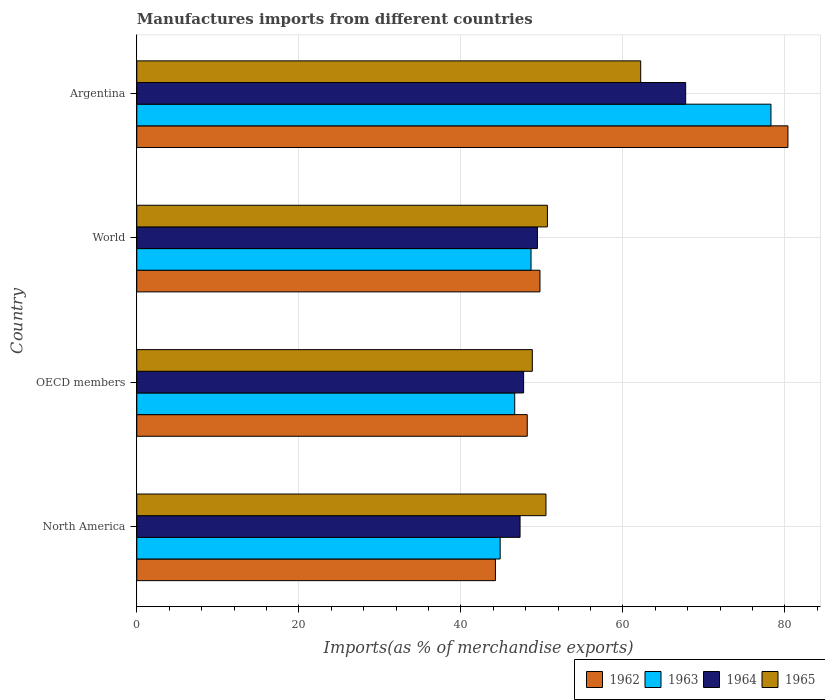How many different coloured bars are there?
Provide a succinct answer. 4. How many groups of bars are there?
Make the answer very short. 4. Are the number of bars on each tick of the Y-axis equal?
Offer a terse response. Yes. How many bars are there on the 2nd tick from the top?
Keep it short and to the point. 4. How many bars are there on the 1st tick from the bottom?
Ensure brevity in your answer.  4. What is the percentage of imports to different countries in 1964 in OECD members?
Your answer should be compact. 47.75. Across all countries, what is the maximum percentage of imports to different countries in 1962?
Ensure brevity in your answer.  80.37. Across all countries, what is the minimum percentage of imports to different countries in 1963?
Offer a terse response. 44.85. In which country was the percentage of imports to different countries in 1965 minimum?
Your answer should be compact. OECD members. What is the total percentage of imports to different countries in 1964 in the graph?
Keep it short and to the point. 212.24. What is the difference between the percentage of imports to different countries in 1964 in North America and that in World?
Provide a succinct answer. -2.14. What is the difference between the percentage of imports to different countries in 1962 in OECD members and the percentage of imports to different countries in 1963 in Argentina?
Your response must be concise. -30.08. What is the average percentage of imports to different countries in 1963 per country?
Provide a short and direct response. 54.61. What is the difference between the percentage of imports to different countries in 1962 and percentage of imports to different countries in 1964 in World?
Make the answer very short. 0.31. What is the ratio of the percentage of imports to different countries in 1963 in Argentina to that in North America?
Provide a succinct answer. 1.75. Is the percentage of imports to different countries in 1964 in Argentina less than that in North America?
Offer a terse response. No. Is the difference between the percentage of imports to different countries in 1962 in Argentina and OECD members greater than the difference between the percentage of imports to different countries in 1964 in Argentina and OECD members?
Offer a very short reply. Yes. What is the difference between the highest and the second highest percentage of imports to different countries in 1962?
Provide a short and direct response. 30.61. What is the difference between the highest and the lowest percentage of imports to different countries in 1964?
Make the answer very short. 20.44. Is the sum of the percentage of imports to different countries in 1962 in OECD members and World greater than the maximum percentage of imports to different countries in 1964 across all countries?
Offer a terse response. Yes. Is it the case that in every country, the sum of the percentage of imports to different countries in 1963 and percentage of imports to different countries in 1962 is greater than the sum of percentage of imports to different countries in 1964 and percentage of imports to different countries in 1965?
Offer a very short reply. No. What does the 1st bar from the top in Argentina represents?
Offer a very short reply. 1965. What does the 4th bar from the bottom in OECD members represents?
Provide a succinct answer. 1965. Is it the case that in every country, the sum of the percentage of imports to different countries in 1964 and percentage of imports to different countries in 1965 is greater than the percentage of imports to different countries in 1963?
Your answer should be compact. Yes. How many bars are there?
Offer a very short reply. 16. Does the graph contain any zero values?
Offer a very short reply. No. Does the graph contain grids?
Your response must be concise. Yes. Where does the legend appear in the graph?
Make the answer very short. Bottom right. What is the title of the graph?
Ensure brevity in your answer.  Manufactures imports from different countries. What is the label or title of the X-axis?
Your answer should be very brief. Imports(as % of merchandise exports). What is the label or title of the Y-axis?
Offer a terse response. Country. What is the Imports(as % of merchandise exports) of 1962 in North America?
Ensure brevity in your answer.  44.26. What is the Imports(as % of merchandise exports) in 1963 in North America?
Your answer should be very brief. 44.85. What is the Imports(as % of merchandise exports) of 1964 in North America?
Give a very brief answer. 47.3. What is the Imports(as % of merchandise exports) in 1965 in North America?
Give a very brief answer. 50.5. What is the Imports(as % of merchandise exports) of 1962 in OECD members?
Your answer should be very brief. 48.19. What is the Imports(as % of merchandise exports) in 1963 in OECD members?
Offer a very short reply. 46.65. What is the Imports(as % of merchandise exports) in 1964 in OECD members?
Give a very brief answer. 47.75. What is the Imports(as % of merchandise exports) in 1965 in OECD members?
Provide a short and direct response. 48.82. What is the Imports(as % of merchandise exports) of 1962 in World?
Your response must be concise. 49.76. What is the Imports(as % of merchandise exports) of 1963 in World?
Make the answer very short. 48.66. What is the Imports(as % of merchandise exports) of 1964 in World?
Give a very brief answer. 49.45. What is the Imports(as % of merchandise exports) in 1965 in World?
Make the answer very short. 50.68. What is the Imports(as % of merchandise exports) in 1962 in Argentina?
Provide a short and direct response. 80.37. What is the Imports(as % of merchandise exports) of 1963 in Argentina?
Offer a terse response. 78.27. What is the Imports(as % of merchandise exports) in 1964 in Argentina?
Give a very brief answer. 67.75. What is the Imports(as % of merchandise exports) in 1965 in Argentina?
Provide a succinct answer. 62.19. Across all countries, what is the maximum Imports(as % of merchandise exports) in 1962?
Provide a short and direct response. 80.37. Across all countries, what is the maximum Imports(as % of merchandise exports) in 1963?
Give a very brief answer. 78.27. Across all countries, what is the maximum Imports(as % of merchandise exports) of 1964?
Provide a succinct answer. 67.75. Across all countries, what is the maximum Imports(as % of merchandise exports) of 1965?
Offer a very short reply. 62.19. Across all countries, what is the minimum Imports(as % of merchandise exports) in 1962?
Your answer should be very brief. 44.26. Across all countries, what is the minimum Imports(as % of merchandise exports) of 1963?
Ensure brevity in your answer.  44.85. Across all countries, what is the minimum Imports(as % of merchandise exports) in 1964?
Your answer should be compact. 47.3. Across all countries, what is the minimum Imports(as % of merchandise exports) of 1965?
Make the answer very short. 48.82. What is the total Imports(as % of merchandise exports) in 1962 in the graph?
Ensure brevity in your answer.  222.58. What is the total Imports(as % of merchandise exports) in 1963 in the graph?
Your answer should be compact. 218.43. What is the total Imports(as % of merchandise exports) of 1964 in the graph?
Ensure brevity in your answer.  212.24. What is the total Imports(as % of merchandise exports) in 1965 in the graph?
Your answer should be very brief. 212.2. What is the difference between the Imports(as % of merchandise exports) of 1962 in North America and that in OECD members?
Your answer should be very brief. -3.93. What is the difference between the Imports(as % of merchandise exports) in 1963 in North America and that in OECD members?
Offer a terse response. -1.8. What is the difference between the Imports(as % of merchandise exports) in 1964 in North America and that in OECD members?
Give a very brief answer. -0.44. What is the difference between the Imports(as % of merchandise exports) in 1965 in North America and that in OECD members?
Give a very brief answer. 1.68. What is the difference between the Imports(as % of merchandise exports) in 1962 in North America and that in World?
Offer a terse response. -5.5. What is the difference between the Imports(as % of merchandise exports) of 1963 in North America and that in World?
Provide a short and direct response. -3.81. What is the difference between the Imports(as % of merchandise exports) in 1964 in North America and that in World?
Make the answer very short. -2.14. What is the difference between the Imports(as % of merchandise exports) of 1965 in North America and that in World?
Keep it short and to the point. -0.18. What is the difference between the Imports(as % of merchandise exports) in 1962 in North America and that in Argentina?
Provide a succinct answer. -36.1. What is the difference between the Imports(as % of merchandise exports) of 1963 in North America and that in Argentina?
Your response must be concise. -33.42. What is the difference between the Imports(as % of merchandise exports) of 1964 in North America and that in Argentina?
Ensure brevity in your answer.  -20.44. What is the difference between the Imports(as % of merchandise exports) in 1965 in North America and that in Argentina?
Keep it short and to the point. -11.69. What is the difference between the Imports(as % of merchandise exports) of 1962 in OECD members and that in World?
Offer a very short reply. -1.57. What is the difference between the Imports(as % of merchandise exports) of 1963 in OECD members and that in World?
Your answer should be very brief. -2.01. What is the difference between the Imports(as % of merchandise exports) in 1964 in OECD members and that in World?
Provide a succinct answer. -1.7. What is the difference between the Imports(as % of merchandise exports) in 1965 in OECD members and that in World?
Your response must be concise. -1.86. What is the difference between the Imports(as % of merchandise exports) in 1962 in OECD members and that in Argentina?
Keep it short and to the point. -32.17. What is the difference between the Imports(as % of merchandise exports) in 1963 in OECD members and that in Argentina?
Your answer should be very brief. -31.62. What is the difference between the Imports(as % of merchandise exports) in 1964 in OECD members and that in Argentina?
Ensure brevity in your answer.  -20. What is the difference between the Imports(as % of merchandise exports) of 1965 in OECD members and that in Argentina?
Your answer should be compact. -13.38. What is the difference between the Imports(as % of merchandise exports) in 1962 in World and that in Argentina?
Ensure brevity in your answer.  -30.61. What is the difference between the Imports(as % of merchandise exports) of 1963 in World and that in Argentina?
Offer a very short reply. -29.61. What is the difference between the Imports(as % of merchandise exports) of 1964 in World and that in Argentina?
Your answer should be compact. -18.3. What is the difference between the Imports(as % of merchandise exports) of 1965 in World and that in Argentina?
Offer a terse response. -11.52. What is the difference between the Imports(as % of merchandise exports) of 1962 in North America and the Imports(as % of merchandise exports) of 1963 in OECD members?
Offer a terse response. -2.38. What is the difference between the Imports(as % of merchandise exports) of 1962 in North America and the Imports(as % of merchandise exports) of 1964 in OECD members?
Offer a very short reply. -3.48. What is the difference between the Imports(as % of merchandise exports) of 1962 in North America and the Imports(as % of merchandise exports) of 1965 in OECD members?
Your answer should be very brief. -4.56. What is the difference between the Imports(as % of merchandise exports) in 1963 in North America and the Imports(as % of merchandise exports) in 1964 in OECD members?
Offer a very short reply. -2.89. What is the difference between the Imports(as % of merchandise exports) of 1963 in North America and the Imports(as % of merchandise exports) of 1965 in OECD members?
Your answer should be very brief. -3.97. What is the difference between the Imports(as % of merchandise exports) in 1964 in North America and the Imports(as % of merchandise exports) in 1965 in OECD members?
Your answer should be compact. -1.52. What is the difference between the Imports(as % of merchandise exports) of 1962 in North America and the Imports(as % of merchandise exports) of 1963 in World?
Ensure brevity in your answer.  -4.4. What is the difference between the Imports(as % of merchandise exports) of 1962 in North America and the Imports(as % of merchandise exports) of 1964 in World?
Offer a terse response. -5.19. What is the difference between the Imports(as % of merchandise exports) in 1962 in North America and the Imports(as % of merchandise exports) in 1965 in World?
Your answer should be very brief. -6.42. What is the difference between the Imports(as % of merchandise exports) of 1963 in North America and the Imports(as % of merchandise exports) of 1964 in World?
Make the answer very short. -4.6. What is the difference between the Imports(as % of merchandise exports) of 1963 in North America and the Imports(as % of merchandise exports) of 1965 in World?
Make the answer very short. -5.83. What is the difference between the Imports(as % of merchandise exports) of 1964 in North America and the Imports(as % of merchandise exports) of 1965 in World?
Your response must be concise. -3.37. What is the difference between the Imports(as % of merchandise exports) of 1962 in North America and the Imports(as % of merchandise exports) of 1963 in Argentina?
Your response must be concise. -34.01. What is the difference between the Imports(as % of merchandise exports) in 1962 in North America and the Imports(as % of merchandise exports) in 1964 in Argentina?
Offer a terse response. -23.48. What is the difference between the Imports(as % of merchandise exports) of 1962 in North America and the Imports(as % of merchandise exports) of 1965 in Argentina?
Keep it short and to the point. -17.93. What is the difference between the Imports(as % of merchandise exports) of 1963 in North America and the Imports(as % of merchandise exports) of 1964 in Argentina?
Keep it short and to the point. -22.89. What is the difference between the Imports(as % of merchandise exports) of 1963 in North America and the Imports(as % of merchandise exports) of 1965 in Argentina?
Keep it short and to the point. -17.34. What is the difference between the Imports(as % of merchandise exports) of 1964 in North America and the Imports(as % of merchandise exports) of 1965 in Argentina?
Offer a very short reply. -14.89. What is the difference between the Imports(as % of merchandise exports) in 1962 in OECD members and the Imports(as % of merchandise exports) in 1963 in World?
Your response must be concise. -0.47. What is the difference between the Imports(as % of merchandise exports) in 1962 in OECD members and the Imports(as % of merchandise exports) in 1964 in World?
Your response must be concise. -1.26. What is the difference between the Imports(as % of merchandise exports) in 1962 in OECD members and the Imports(as % of merchandise exports) in 1965 in World?
Offer a terse response. -2.49. What is the difference between the Imports(as % of merchandise exports) in 1963 in OECD members and the Imports(as % of merchandise exports) in 1964 in World?
Give a very brief answer. -2.8. What is the difference between the Imports(as % of merchandise exports) in 1963 in OECD members and the Imports(as % of merchandise exports) in 1965 in World?
Your answer should be compact. -4.03. What is the difference between the Imports(as % of merchandise exports) of 1964 in OECD members and the Imports(as % of merchandise exports) of 1965 in World?
Ensure brevity in your answer.  -2.93. What is the difference between the Imports(as % of merchandise exports) in 1962 in OECD members and the Imports(as % of merchandise exports) in 1963 in Argentina?
Offer a very short reply. -30.08. What is the difference between the Imports(as % of merchandise exports) in 1962 in OECD members and the Imports(as % of merchandise exports) in 1964 in Argentina?
Your answer should be very brief. -19.55. What is the difference between the Imports(as % of merchandise exports) of 1962 in OECD members and the Imports(as % of merchandise exports) of 1965 in Argentina?
Give a very brief answer. -14. What is the difference between the Imports(as % of merchandise exports) of 1963 in OECD members and the Imports(as % of merchandise exports) of 1964 in Argentina?
Provide a short and direct response. -21.1. What is the difference between the Imports(as % of merchandise exports) of 1963 in OECD members and the Imports(as % of merchandise exports) of 1965 in Argentina?
Offer a terse response. -15.55. What is the difference between the Imports(as % of merchandise exports) of 1964 in OECD members and the Imports(as % of merchandise exports) of 1965 in Argentina?
Provide a succinct answer. -14.45. What is the difference between the Imports(as % of merchandise exports) in 1962 in World and the Imports(as % of merchandise exports) in 1963 in Argentina?
Provide a succinct answer. -28.51. What is the difference between the Imports(as % of merchandise exports) in 1962 in World and the Imports(as % of merchandise exports) in 1964 in Argentina?
Offer a very short reply. -17.98. What is the difference between the Imports(as % of merchandise exports) of 1962 in World and the Imports(as % of merchandise exports) of 1965 in Argentina?
Offer a terse response. -12.43. What is the difference between the Imports(as % of merchandise exports) of 1963 in World and the Imports(as % of merchandise exports) of 1964 in Argentina?
Give a very brief answer. -19.09. What is the difference between the Imports(as % of merchandise exports) in 1963 in World and the Imports(as % of merchandise exports) in 1965 in Argentina?
Ensure brevity in your answer.  -13.54. What is the difference between the Imports(as % of merchandise exports) of 1964 in World and the Imports(as % of merchandise exports) of 1965 in Argentina?
Offer a very short reply. -12.75. What is the average Imports(as % of merchandise exports) of 1962 per country?
Provide a short and direct response. 55.65. What is the average Imports(as % of merchandise exports) of 1963 per country?
Your response must be concise. 54.61. What is the average Imports(as % of merchandise exports) of 1964 per country?
Provide a succinct answer. 53.06. What is the average Imports(as % of merchandise exports) of 1965 per country?
Provide a succinct answer. 53.05. What is the difference between the Imports(as % of merchandise exports) of 1962 and Imports(as % of merchandise exports) of 1963 in North America?
Ensure brevity in your answer.  -0.59. What is the difference between the Imports(as % of merchandise exports) of 1962 and Imports(as % of merchandise exports) of 1964 in North America?
Offer a terse response. -3.04. What is the difference between the Imports(as % of merchandise exports) of 1962 and Imports(as % of merchandise exports) of 1965 in North America?
Your answer should be very brief. -6.24. What is the difference between the Imports(as % of merchandise exports) of 1963 and Imports(as % of merchandise exports) of 1964 in North America?
Give a very brief answer. -2.45. What is the difference between the Imports(as % of merchandise exports) of 1963 and Imports(as % of merchandise exports) of 1965 in North America?
Your answer should be compact. -5.65. What is the difference between the Imports(as % of merchandise exports) in 1964 and Imports(as % of merchandise exports) in 1965 in North America?
Your answer should be very brief. -3.2. What is the difference between the Imports(as % of merchandise exports) in 1962 and Imports(as % of merchandise exports) in 1963 in OECD members?
Your answer should be very brief. 1.55. What is the difference between the Imports(as % of merchandise exports) in 1962 and Imports(as % of merchandise exports) in 1964 in OECD members?
Your answer should be very brief. 0.45. What is the difference between the Imports(as % of merchandise exports) in 1962 and Imports(as % of merchandise exports) in 1965 in OECD members?
Your answer should be compact. -0.63. What is the difference between the Imports(as % of merchandise exports) in 1963 and Imports(as % of merchandise exports) in 1964 in OECD members?
Provide a succinct answer. -1.1. What is the difference between the Imports(as % of merchandise exports) of 1963 and Imports(as % of merchandise exports) of 1965 in OECD members?
Your response must be concise. -2.17. What is the difference between the Imports(as % of merchandise exports) in 1964 and Imports(as % of merchandise exports) in 1965 in OECD members?
Give a very brief answer. -1.07. What is the difference between the Imports(as % of merchandise exports) of 1962 and Imports(as % of merchandise exports) of 1963 in World?
Make the answer very short. 1.1. What is the difference between the Imports(as % of merchandise exports) in 1962 and Imports(as % of merchandise exports) in 1964 in World?
Give a very brief answer. 0.31. What is the difference between the Imports(as % of merchandise exports) of 1962 and Imports(as % of merchandise exports) of 1965 in World?
Your response must be concise. -0.92. What is the difference between the Imports(as % of merchandise exports) in 1963 and Imports(as % of merchandise exports) in 1964 in World?
Offer a very short reply. -0.79. What is the difference between the Imports(as % of merchandise exports) of 1963 and Imports(as % of merchandise exports) of 1965 in World?
Offer a very short reply. -2.02. What is the difference between the Imports(as % of merchandise exports) of 1964 and Imports(as % of merchandise exports) of 1965 in World?
Give a very brief answer. -1.23. What is the difference between the Imports(as % of merchandise exports) in 1962 and Imports(as % of merchandise exports) in 1963 in Argentina?
Your answer should be compact. 2.1. What is the difference between the Imports(as % of merchandise exports) in 1962 and Imports(as % of merchandise exports) in 1964 in Argentina?
Provide a short and direct response. 12.62. What is the difference between the Imports(as % of merchandise exports) in 1962 and Imports(as % of merchandise exports) in 1965 in Argentina?
Offer a terse response. 18.17. What is the difference between the Imports(as % of merchandise exports) of 1963 and Imports(as % of merchandise exports) of 1964 in Argentina?
Offer a terse response. 10.52. What is the difference between the Imports(as % of merchandise exports) in 1963 and Imports(as % of merchandise exports) in 1965 in Argentina?
Offer a terse response. 16.08. What is the difference between the Imports(as % of merchandise exports) in 1964 and Imports(as % of merchandise exports) in 1965 in Argentina?
Offer a terse response. 5.55. What is the ratio of the Imports(as % of merchandise exports) of 1962 in North America to that in OECD members?
Provide a short and direct response. 0.92. What is the ratio of the Imports(as % of merchandise exports) in 1963 in North America to that in OECD members?
Offer a terse response. 0.96. What is the ratio of the Imports(as % of merchandise exports) of 1965 in North America to that in OECD members?
Give a very brief answer. 1.03. What is the ratio of the Imports(as % of merchandise exports) in 1962 in North America to that in World?
Provide a succinct answer. 0.89. What is the ratio of the Imports(as % of merchandise exports) of 1963 in North America to that in World?
Provide a succinct answer. 0.92. What is the ratio of the Imports(as % of merchandise exports) of 1964 in North America to that in World?
Your answer should be very brief. 0.96. What is the ratio of the Imports(as % of merchandise exports) of 1962 in North America to that in Argentina?
Offer a terse response. 0.55. What is the ratio of the Imports(as % of merchandise exports) of 1963 in North America to that in Argentina?
Provide a succinct answer. 0.57. What is the ratio of the Imports(as % of merchandise exports) in 1964 in North America to that in Argentina?
Provide a short and direct response. 0.7. What is the ratio of the Imports(as % of merchandise exports) in 1965 in North America to that in Argentina?
Provide a succinct answer. 0.81. What is the ratio of the Imports(as % of merchandise exports) of 1962 in OECD members to that in World?
Ensure brevity in your answer.  0.97. What is the ratio of the Imports(as % of merchandise exports) in 1963 in OECD members to that in World?
Ensure brevity in your answer.  0.96. What is the ratio of the Imports(as % of merchandise exports) of 1964 in OECD members to that in World?
Ensure brevity in your answer.  0.97. What is the ratio of the Imports(as % of merchandise exports) of 1965 in OECD members to that in World?
Provide a short and direct response. 0.96. What is the ratio of the Imports(as % of merchandise exports) in 1962 in OECD members to that in Argentina?
Give a very brief answer. 0.6. What is the ratio of the Imports(as % of merchandise exports) of 1963 in OECD members to that in Argentina?
Provide a succinct answer. 0.6. What is the ratio of the Imports(as % of merchandise exports) of 1964 in OECD members to that in Argentina?
Provide a succinct answer. 0.7. What is the ratio of the Imports(as % of merchandise exports) in 1965 in OECD members to that in Argentina?
Your answer should be very brief. 0.78. What is the ratio of the Imports(as % of merchandise exports) in 1962 in World to that in Argentina?
Your response must be concise. 0.62. What is the ratio of the Imports(as % of merchandise exports) of 1963 in World to that in Argentina?
Ensure brevity in your answer.  0.62. What is the ratio of the Imports(as % of merchandise exports) of 1964 in World to that in Argentina?
Ensure brevity in your answer.  0.73. What is the ratio of the Imports(as % of merchandise exports) of 1965 in World to that in Argentina?
Provide a succinct answer. 0.81. What is the difference between the highest and the second highest Imports(as % of merchandise exports) in 1962?
Ensure brevity in your answer.  30.61. What is the difference between the highest and the second highest Imports(as % of merchandise exports) of 1963?
Your answer should be very brief. 29.61. What is the difference between the highest and the second highest Imports(as % of merchandise exports) of 1964?
Provide a short and direct response. 18.3. What is the difference between the highest and the second highest Imports(as % of merchandise exports) of 1965?
Provide a succinct answer. 11.52. What is the difference between the highest and the lowest Imports(as % of merchandise exports) of 1962?
Your answer should be very brief. 36.1. What is the difference between the highest and the lowest Imports(as % of merchandise exports) of 1963?
Your answer should be compact. 33.42. What is the difference between the highest and the lowest Imports(as % of merchandise exports) in 1964?
Keep it short and to the point. 20.44. What is the difference between the highest and the lowest Imports(as % of merchandise exports) of 1965?
Provide a succinct answer. 13.38. 